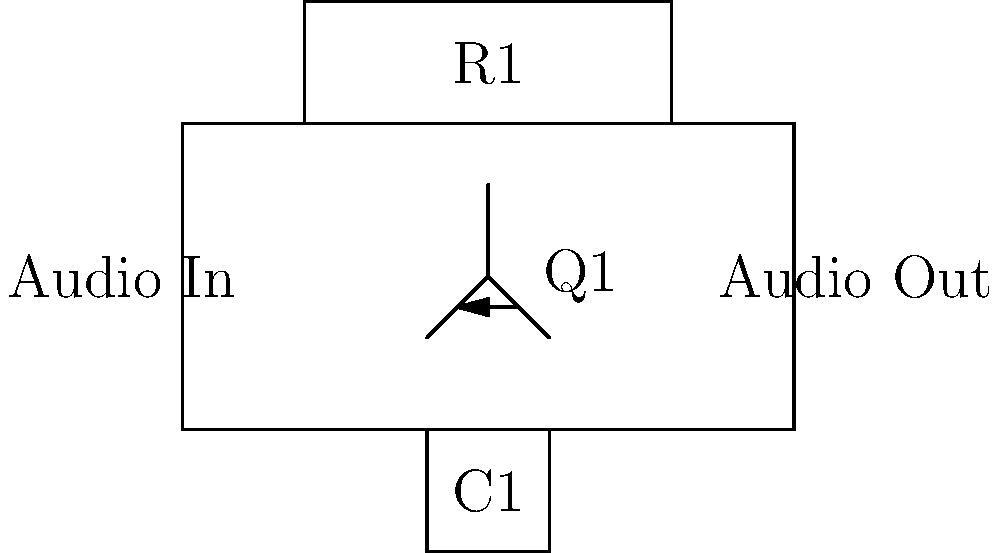In the given simple audio amplifier circuit diagram, which component is responsible for blocking DC voltage while allowing AC audio signals to pass through? To answer this question, let's break down the components and their functions in a simple audio amplifier:

1. Resistor (R1): Provides biasing for the transistor and helps set the operating point.

2. Transistor (Q1): Amplifies the input signal.

3. Capacitor (C1): This is the key component for answering the question.

The capacitor C1 in this circuit serves two important functions:

a) DC Blocking: It blocks any DC component of the input signal, preventing it from affecting the transistor's biasing.

b) AC Coupling: It allows AC audio signals to pass through, coupling the input audio to the amplifier stage.

The capacitor achieves this because its impedance varies with frequency:

- For DC (0 Hz), the capacitor acts as an open circuit, effectively blocking DC.
- For AC signals (audio frequencies), the capacitor's impedance decreases, allowing these signals to pass through.

The formula for capacitive reactance is:

$$ X_C = \frac{1}{2\pi fC} $$

Where $f$ is frequency and $C$ is capacitance. As frequency increases, $X_C$ decreases, allowing higher frequency signals (like audio) to pass more easily.

Therefore, the capacitor C1 is responsible for blocking DC voltage while allowing AC audio signals to pass through in this simple audio amplifier circuit.
Answer: Capacitor (C1) 